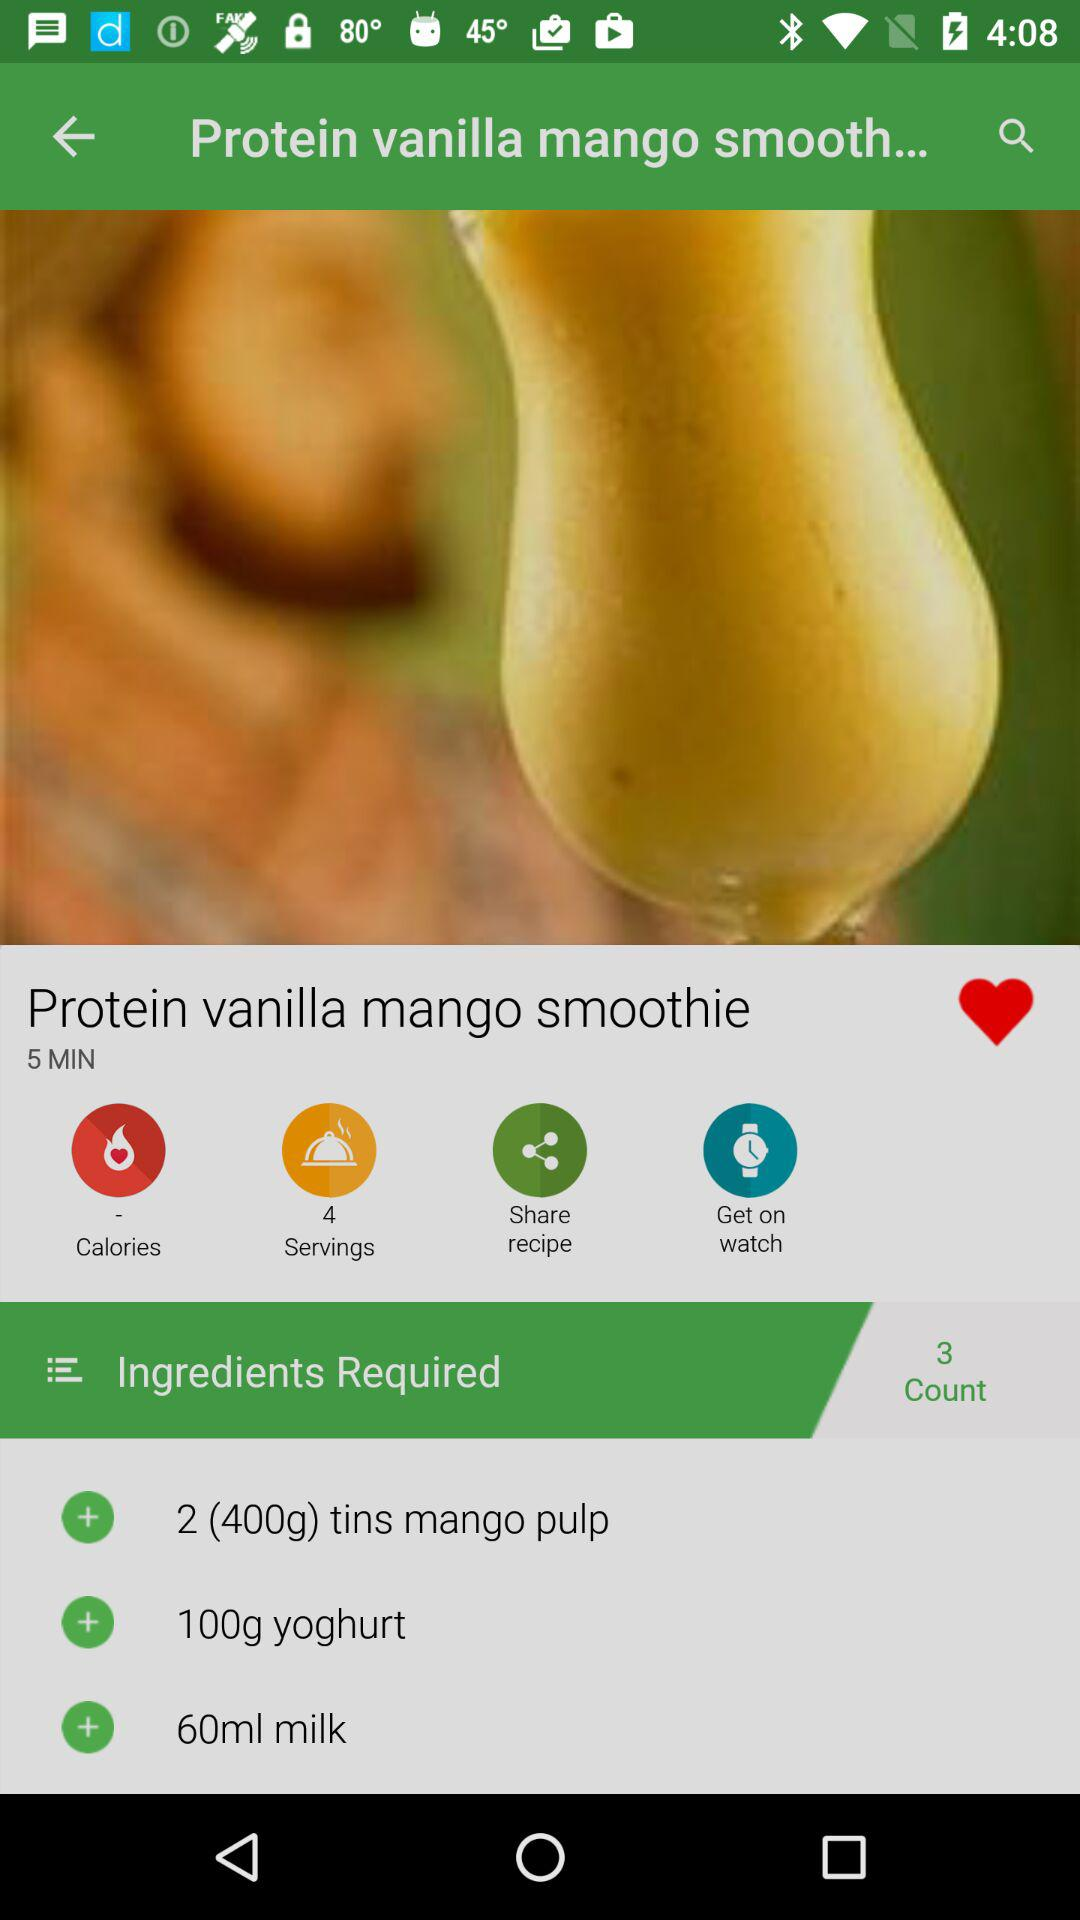How many cups of milk are needed?
When the provided information is insufficient, respond with <no answer>. <no answer> 